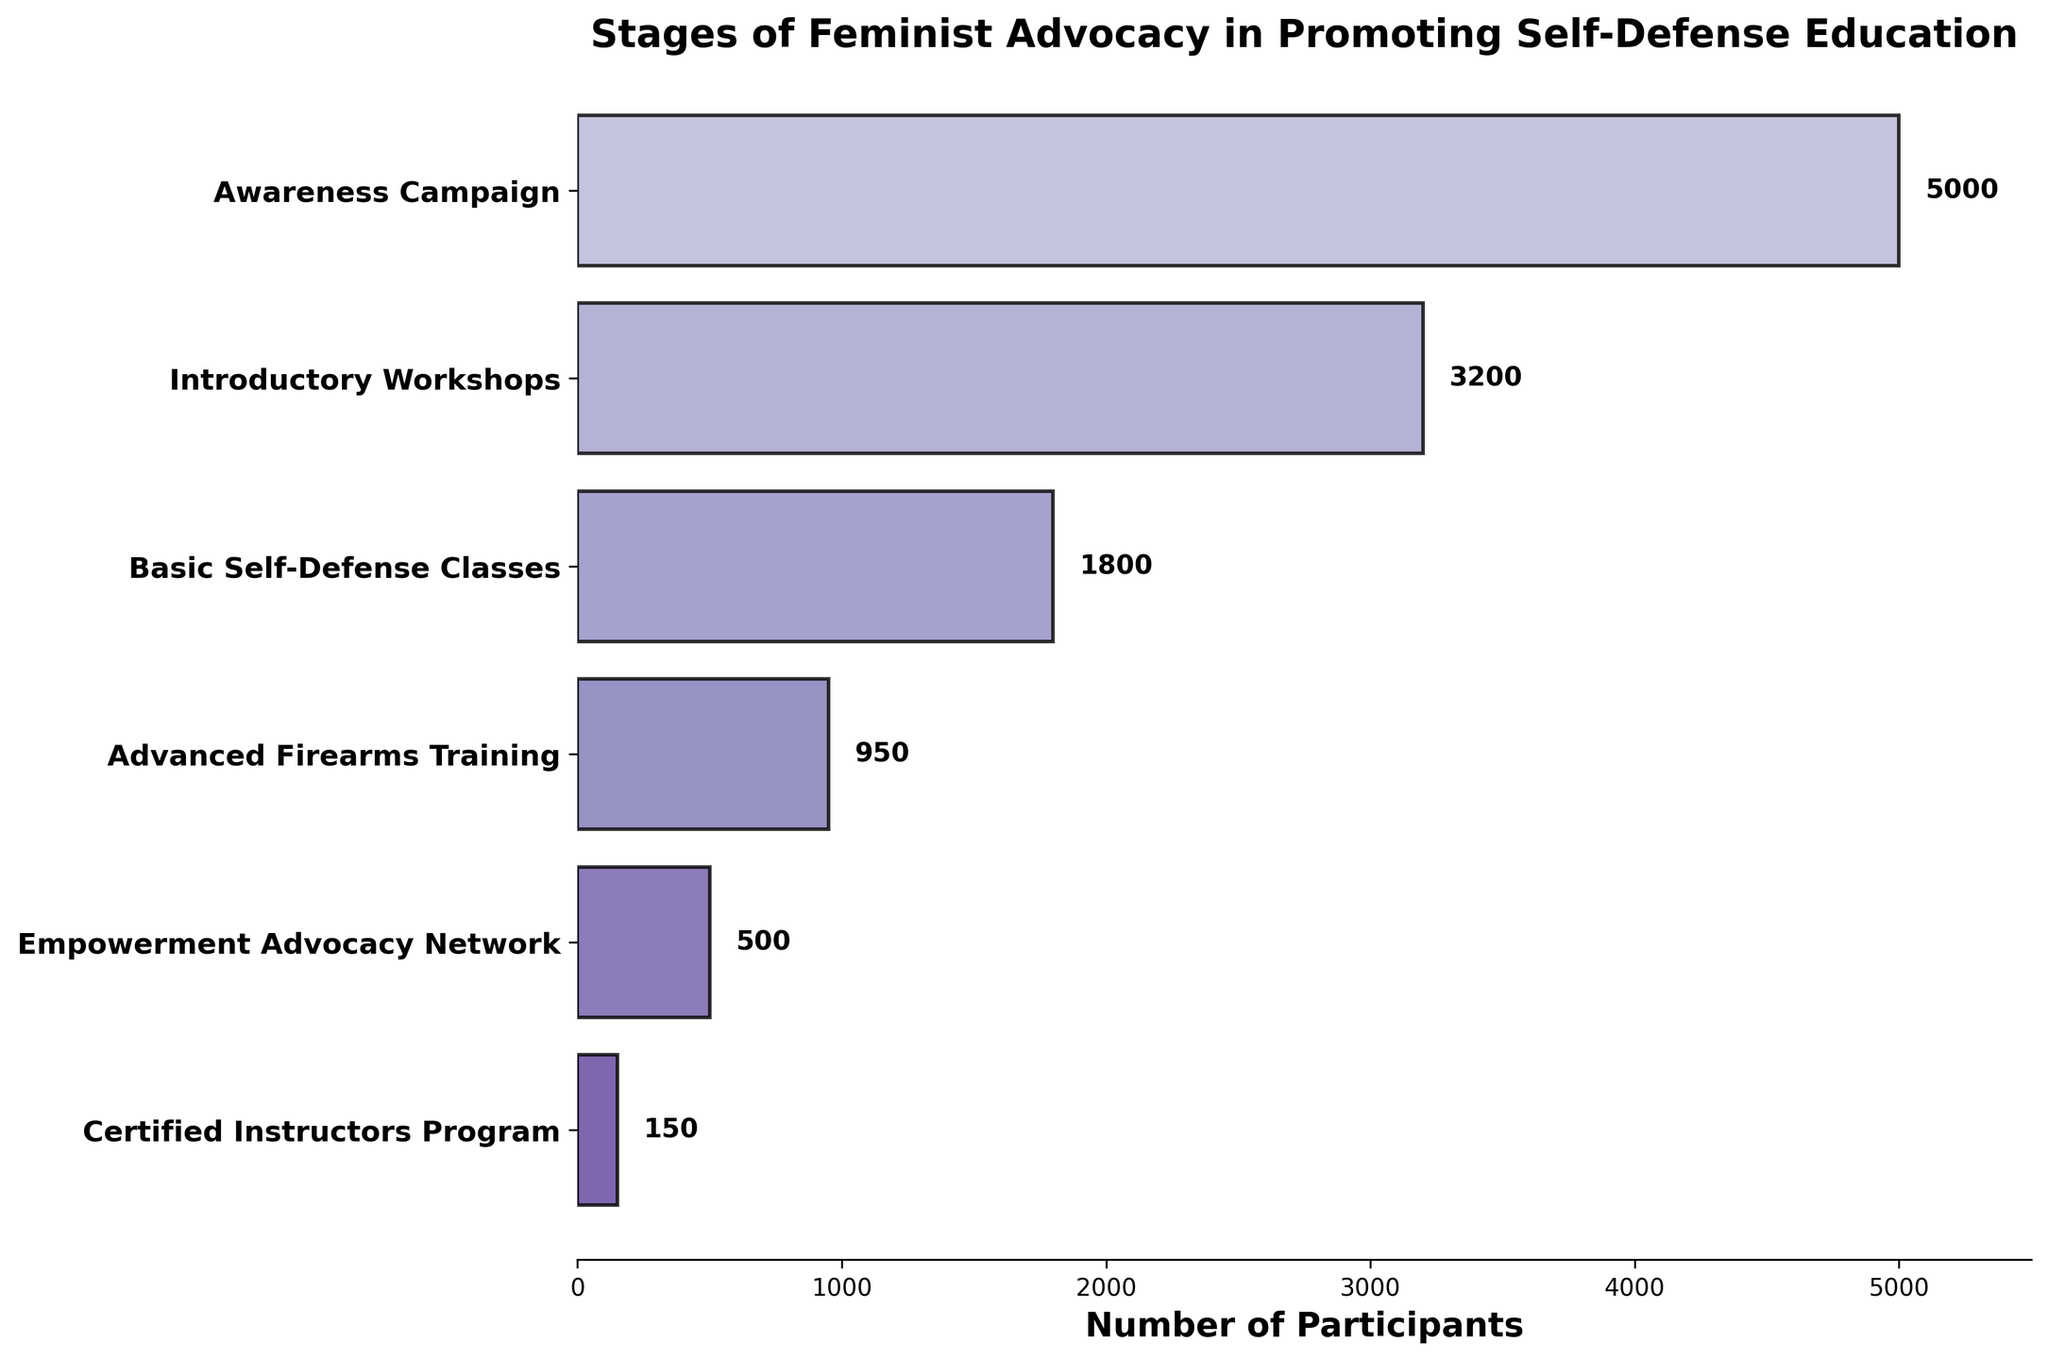How many stages are displayed in the funnel chart? There are six stages indicated by six horizontal bars in the funnel chart.
Answer: 6 What is the title of the figure? The title is written at the top of the chart and states the purpose of the visual representation.
Answer: Stages of Feminist Advocacy in Promoting Self-Defense Education Which stage has the highest number of participants? By comparing the lengths of the horizontal bars, the first stage has the maximum number of participants.
Answer: Awareness Campaign Which stage has the least number of participants? By comparing the lengths of the horizontal bars, the last stage has the minimum number of participants.
Answer: Certified Instructors Program What is the difference in the number of participants between the "Awareness Campaign" and "Certified Instructors Program"? The "Awareness Campaign" has 5000 participants and the "Certified Instructors Program" has 150 participants. The difference is the subtraction of these two numbers. 5000 - 150 = 4850
Answer: 4850 How many participants are there in the "Advanced Firearms Training" stage? The text value beside the bar representing the "Advanced Firearms Training" stage gives this information.
Answer: 950 What is the sum of participants in the "Introductory Workshops" and "Basic Self-Defense Classes"? The "Introductory Workshops" have 3200 participants and the "Basic Self-Defense Classes" have 1800 participants. Adding these two numbers gives 3200 + 1800 = 5000
Answer: 5000 How does the number of participants change from "Awareness Campaign" to "Empowerment Advocacy Network"? The "Awareness Campaign" has 5000 participants, "Introductory Workshops" have 3200, "Basic Self-Defense Classes" have 1800, "Advanced Firearms Training" has 950, and "Empowerment Advocacy Network" has 500 participants. The number of participants decreases at each stage.
Answer: Decreases Which two stages have the closest number of participants? Comparing the number of participants in each stage, the "Basic Self-Defense Classes" with 1800 participants and the "Advanced Firearms Training" with 950 participants have the smallest difference of 850 participants.
Answer: Basic Self-Defense Classes and Advanced Firearms Training What is the average number of participants across all stages? The total number of participants is the sum of 5000 (Awareness Campaign), 3200 (Introductory Workshops), 1800 (Basic Self-Defense Classes), 950 (Advanced Firearms Training), 500 (Empowerment Advocacy Network), and 150 (Certified Instructors Program), which is 11600. There are 6 stages, so the average is 11600 / 6 = 1933.33
Answer: 1933.33 